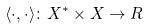Convert formula to latex. <formula><loc_0><loc_0><loc_500><loc_500>\langle \cdot , \cdot \rangle \colon X ^ { * } \times X \rightarrow R</formula> 